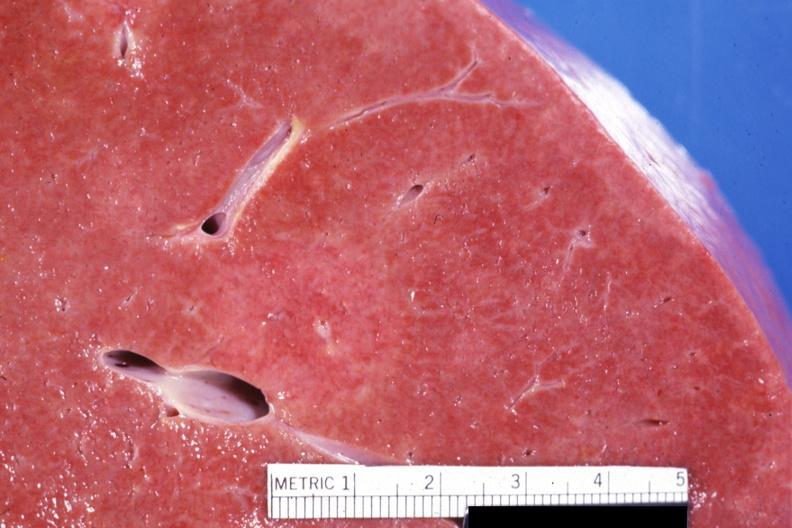s hepatobiliary present?
Answer the question using a single word or phrase. Yes 